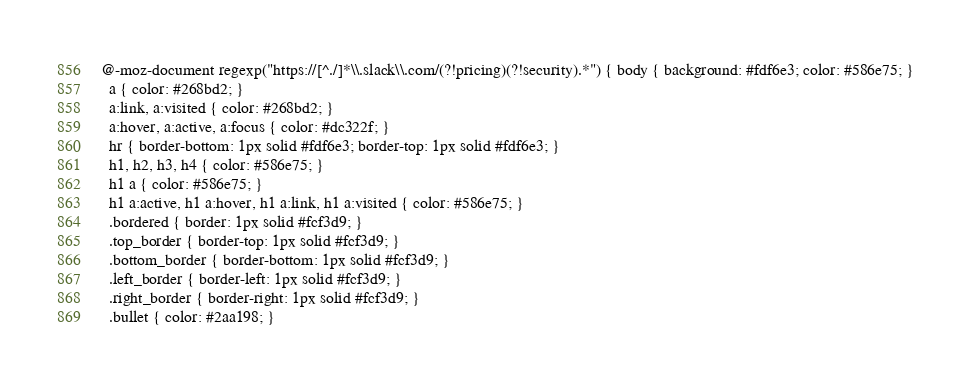Convert code to text. <code><loc_0><loc_0><loc_500><loc_500><_CSS_>@-moz-document regexp("https://[^./]*\\.slack\\.com/(?!pricing)(?!security).*") { body { background: #fdf6e3; color: #586e75; }
  a { color: #268bd2; }
  a:link, a:visited { color: #268bd2; }
  a:hover, a:active, a:focus { color: #dc322f; }
  hr { border-bottom: 1px solid #fdf6e3; border-top: 1px solid #fdf6e3; }
  h1, h2, h3, h4 { color: #586e75; }
  h1 a { color: #586e75; }
  h1 a:active, h1 a:hover, h1 a:link, h1 a:visited { color: #586e75; }
  .bordered { border: 1px solid #fcf3d9; }
  .top_border { border-top: 1px solid #fcf3d9; }
  .bottom_border { border-bottom: 1px solid #fcf3d9; }
  .left_border { border-left: 1px solid #fcf3d9; }
  .right_border { border-right: 1px solid #fcf3d9; }
  .bullet { color: #2aa198; }</code> 